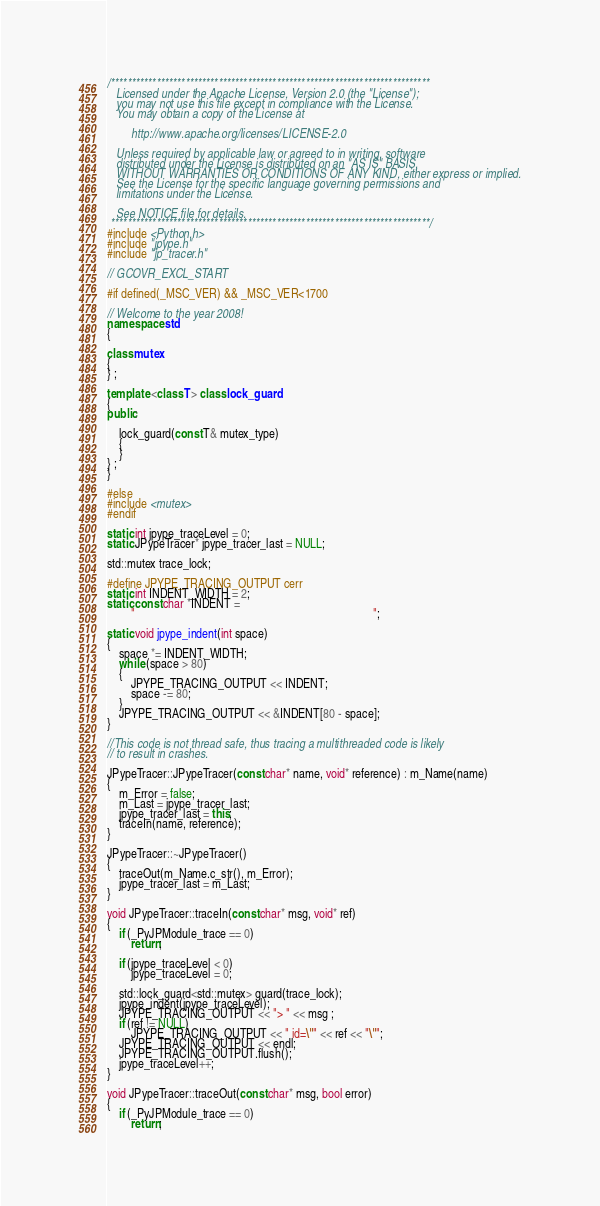Convert code to text. <code><loc_0><loc_0><loc_500><loc_500><_C++_>/*****************************************************************************
   Licensed under the Apache License, Version 2.0 (the "License");
   you may not use this file except in compliance with the License.
   You may obtain a copy of the License at

		http://www.apache.org/licenses/LICENSE-2.0

   Unless required by applicable law or agreed to in writing, software
   distributed under the License is distributed on an "AS IS" BASIS,
   WITHOUT WARRANTIES OR CONDITIONS OF ANY KIND, either express or implied.
   See the License for the specific language governing permissions and
   limitations under the License.

   See NOTICE file for details.
 *****************************************************************************/
#include <Python.h>
#include "jpype.h"
#include "jp_tracer.h"

// GCOVR_EXCL_START

#if defined(_MSC_VER) && _MSC_VER<1700

// Welcome to the year 2008!
namespace std
{

class mutex
{
} ;

template <class T> class lock_guard
{
public:

	lock_guard(const T& mutex_type)
	{
	}
} ;
}

#else
#include <mutex>
#endif

static int jpype_traceLevel = 0;
static JPypeTracer* jpype_tracer_last = NULL;

std::mutex trace_lock;

#define JPYPE_TRACING_OUTPUT cerr
static int INDENT_WIDTH = 2;
static const char *INDENT =
		"                                                                                ";

static void jpype_indent(int space)
{
	space *= INDENT_WIDTH;
	while (space > 80)
	{
		JPYPE_TRACING_OUTPUT << INDENT;
		space -= 80;
	}
	JPYPE_TRACING_OUTPUT << &INDENT[80 - space];
}

//This code is not thread safe, thus tracing a multithreaded code is likely
// to result in crashes.

JPypeTracer::JPypeTracer(const char* name, void* reference) : m_Name(name)
{
	m_Error = false;
	m_Last = jpype_tracer_last;
	jpype_tracer_last = this;
	traceIn(name, reference);
}

JPypeTracer::~JPypeTracer()
{
	traceOut(m_Name.c_str(), m_Error);
	jpype_tracer_last = m_Last;
}

void JPypeTracer::traceIn(const char* msg, void* ref)
{
	if (_PyJPModule_trace == 0)
		return;

	if (jpype_traceLevel < 0)
		jpype_traceLevel = 0;

	std::lock_guard<std::mutex> guard(trace_lock);
	jpype_indent(jpype_traceLevel);
	JPYPE_TRACING_OUTPUT << "> " << msg ;
	if (ref != NULL)
		JPYPE_TRACING_OUTPUT << " id=\"" << ref << "\"";
	JPYPE_TRACING_OUTPUT << endl;
	JPYPE_TRACING_OUTPUT.flush();
	jpype_traceLevel++;
}

void JPypeTracer::traceOut(const char* msg, bool error)
{
	if (_PyJPModule_trace == 0)
		return;
</code> 